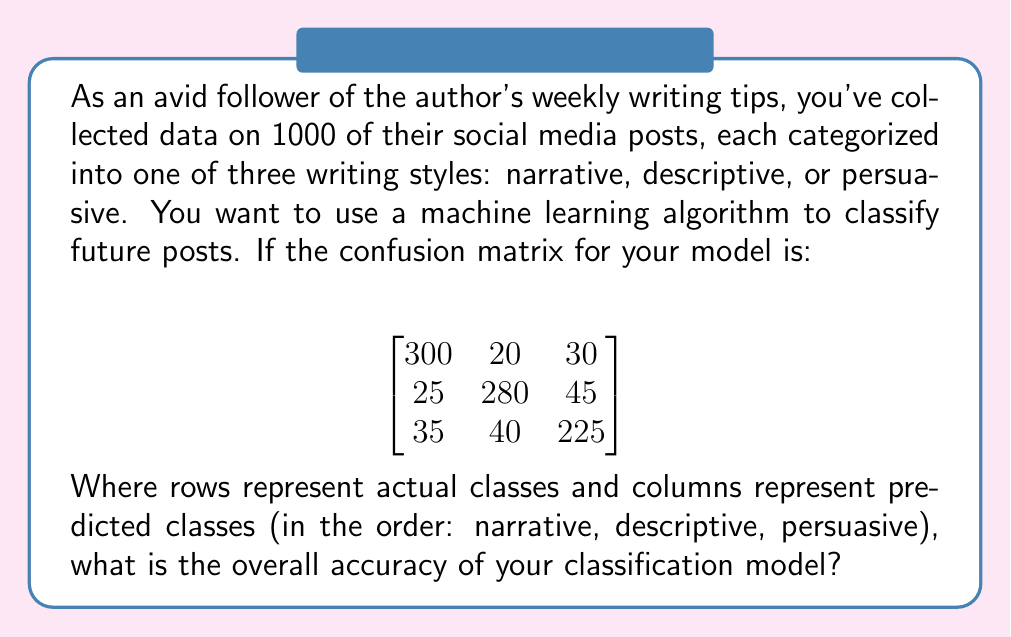Solve this math problem. To solve this problem, we need to understand the concept of accuracy in classification algorithms and how to calculate it using a confusion matrix.

1. The confusion matrix shows the performance of a classification model:
   - Rows represent actual classes
   - Columns represent predicted classes
   - Each cell shows the number of instances for a particular actual-predicted combination

2. The overall accuracy is calculated by dividing the sum of correct predictions (diagonal elements) by the total number of instances:

   $$ \text{Accuracy} = \frac{\text{Number of correct predictions}}{\text{Total number of predictions}} $$

3. From the given confusion matrix:
   - Correct predictions for narrative: 300
   - Correct predictions for descriptive: 280
   - Correct predictions for persuasive: 225

4. Sum of correct predictions:
   $$ 300 + 280 + 225 = 805 $$

5. Total number of instances:
   $$ (300 + 20 + 30) + (25 + 280 + 45) + (35 + 40 + 225) = 1000 $$

6. Calculate the accuracy:
   $$ \text{Accuracy} = \frac{805}{1000} = 0.805 $$

7. Convert to percentage:
   $$ 0.805 \times 100\% = 80.5\% $$

Therefore, the overall accuracy of the classification model is 80.5%.
Answer: 80.5% 